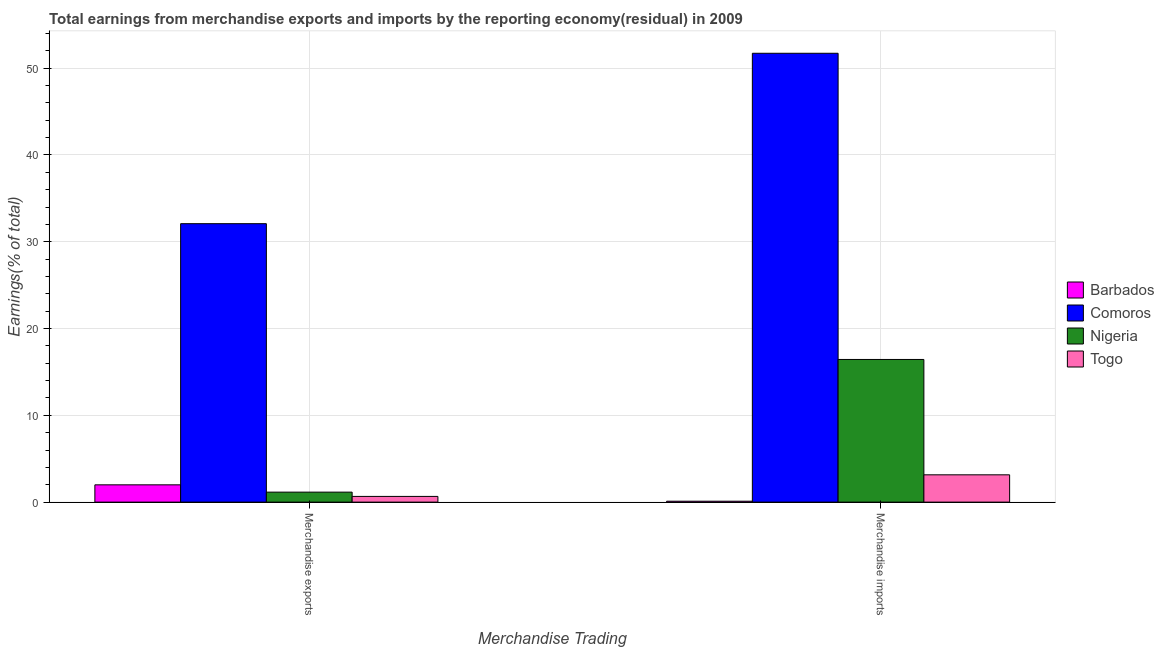Are the number of bars per tick equal to the number of legend labels?
Provide a short and direct response. Yes. How many bars are there on the 1st tick from the right?
Provide a succinct answer. 4. What is the label of the 2nd group of bars from the left?
Provide a succinct answer. Merchandise imports. What is the earnings from merchandise exports in Nigeria?
Your answer should be very brief. 1.15. Across all countries, what is the maximum earnings from merchandise exports?
Make the answer very short. 32.08. Across all countries, what is the minimum earnings from merchandise imports?
Provide a succinct answer. 0.1. In which country was the earnings from merchandise exports maximum?
Your answer should be compact. Comoros. In which country was the earnings from merchandise exports minimum?
Your answer should be very brief. Togo. What is the total earnings from merchandise exports in the graph?
Your response must be concise. 35.89. What is the difference between the earnings from merchandise exports in Barbados and that in Nigeria?
Your answer should be compact. 0.84. What is the difference between the earnings from merchandise imports in Togo and the earnings from merchandise exports in Comoros?
Your answer should be compact. -28.94. What is the average earnings from merchandise exports per country?
Your answer should be very brief. 8.97. What is the difference between the earnings from merchandise imports and earnings from merchandise exports in Comoros?
Provide a succinct answer. 19.64. What is the ratio of the earnings from merchandise exports in Togo to that in Barbados?
Provide a short and direct response. 0.33. In how many countries, is the earnings from merchandise exports greater than the average earnings from merchandise exports taken over all countries?
Make the answer very short. 1. What does the 4th bar from the left in Merchandise imports represents?
Provide a succinct answer. Togo. What does the 4th bar from the right in Merchandise imports represents?
Your answer should be very brief. Barbados. How many bars are there?
Your answer should be compact. 8. How many countries are there in the graph?
Make the answer very short. 4. What is the difference between two consecutive major ticks on the Y-axis?
Provide a succinct answer. 10. Are the values on the major ticks of Y-axis written in scientific E-notation?
Your response must be concise. No. How are the legend labels stacked?
Provide a succinct answer. Vertical. What is the title of the graph?
Keep it short and to the point. Total earnings from merchandise exports and imports by the reporting economy(residual) in 2009. Does "Haiti" appear as one of the legend labels in the graph?
Your answer should be compact. No. What is the label or title of the X-axis?
Provide a succinct answer. Merchandise Trading. What is the label or title of the Y-axis?
Offer a terse response. Earnings(% of total). What is the Earnings(% of total) of Barbados in Merchandise exports?
Your answer should be compact. 1.99. What is the Earnings(% of total) of Comoros in Merchandise exports?
Ensure brevity in your answer.  32.08. What is the Earnings(% of total) in Nigeria in Merchandise exports?
Keep it short and to the point. 1.15. What is the Earnings(% of total) of Togo in Merchandise exports?
Make the answer very short. 0.66. What is the Earnings(% of total) of Barbados in Merchandise imports?
Your answer should be very brief. 0.1. What is the Earnings(% of total) of Comoros in Merchandise imports?
Offer a very short reply. 51.72. What is the Earnings(% of total) in Nigeria in Merchandise imports?
Offer a terse response. 16.44. What is the Earnings(% of total) of Togo in Merchandise imports?
Provide a short and direct response. 3.15. Across all Merchandise Trading, what is the maximum Earnings(% of total) of Barbados?
Your answer should be very brief. 1.99. Across all Merchandise Trading, what is the maximum Earnings(% of total) of Comoros?
Keep it short and to the point. 51.72. Across all Merchandise Trading, what is the maximum Earnings(% of total) of Nigeria?
Offer a very short reply. 16.44. Across all Merchandise Trading, what is the maximum Earnings(% of total) in Togo?
Provide a succinct answer. 3.15. Across all Merchandise Trading, what is the minimum Earnings(% of total) of Barbados?
Offer a very short reply. 0.1. Across all Merchandise Trading, what is the minimum Earnings(% of total) in Comoros?
Provide a succinct answer. 32.08. Across all Merchandise Trading, what is the minimum Earnings(% of total) in Nigeria?
Keep it short and to the point. 1.15. Across all Merchandise Trading, what is the minimum Earnings(% of total) of Togo?
Ensure brevity in your answer.  0.66. What is the total Earnings(% of total) in Barbados in the graph?
Offer a terse response. 2.1. What is the total Earnings(% of total) of Comoros in the graph?
Offer a very short reply. 83.8. What is the total Earnings(% of total) in Nigeria in the graph?
Give a very brief answer. 17.59. What is the total Earnings(% of total) in Togo in the graph?
Offer a very short reply. 3.8. What is the difference between the Earnings(% of total) in Barbados in Merchandise exports and that in Merchandise imports?
Your response must be concise. 1.89. What is the difference between the Earnings(% of total) in Comoros in Merchandise exports and that in Merchandise imports?
Provide a short and direct response. -19.64. What is the difference between the Earnings(% of total) of Nigeria in Merchandise exports and that in Merchandise imports?
Your response must be concise. -15.29. What is the difference between the Earnings(% of total) in Togo in Merchandise exports and that in Merchandise imports?
Ensure brevity in your answer.  -2.49. What is the difference between the Earnings(% of total) of Barbados in Merchandise exports and the Earnings(% of total) of Comoros in Merchandise imports?
Give a very brief answer. -49.73. What is the difference between the Earnings(% of total) in Barbados in Merchandise exports and the Earnings(% of total) in Nigeria in Merchandise imports?
Make the answer very short. -14.45. What is the difference between the Earnings(% of total) in Barbados in Merchandise exports and the Earnings(% of total) in Togo in Merchandise imports?
Your answer should be very brief. -1.15. What is the difference between the Earnings(% of total) of Comoros in Merchandise exports and the Earnings(% of total) of Nigeria in Merchandise imports?
Offer a very short reply. 15.65. What is the difference between the Earnings(% of total) of Comoros in Merchandise exports and the Earnings(% of total) of Togo in Merchandise imports?
Offer a terse response. 28.94. What is the difference between the Earnings(% of total) in Nigeria in Merchandise exports and the Earnings(% of total) in Togo in Merchandise imports?
Provide a short and direct response. -1.99. What is the average Earnings(% of total) in Barbados per Merchandise Trading?
Keep it short and to the point. 1.05. What is the average Earnings(% of total) in Comoros per Merchandise Trading?
Keep it short and to the point. 41.9. What is the average Earnings(% of total) in Nigeria per Merchandise Trading?
Offer a terse response. 8.8. What is the average Earnings(% of total) in Togo per Merchandise Trading?
Provide a short and direct response. 1.9. What is the difference between the Earnings(% of total) in Barbados and Earnings(% of total) in Comoros in Merchandise exports?
Your answer should be very brief. -30.09. What is the difference between the Earnings(% of total) of Barbados and Earnings(% of total) of Nigeria in Merchandise exports?
Your answer should be compact. 0.84. What is the difference between the Earnings(% of total) in Barbados and Earnings(% of total) in Togo in Merchandise exports?
Provide a short and direct response. 1.34. What is the difference between the Earnings(% of total) of Comoros and Earnings(% of total) of Nigeria in Merchandise exports?
Make the answer very short. 30.93. What is the difference between the Earnings(% of total) of Comoros and Earnings(% of total) of Togo in Merchandise exports?
Your answer should be very brief. 31.43. What is the difference between the Earnings(% of total) in Nigeria and Earnings(% of total) in Togo in Merchandise exports?
Offer a very short reply. 0.49. What is the difference between the Earnings(% of total) of Barbados and Earnings(% of total) of Comoros in Merchandise imports?
Provide a succinct answer. -51.61. What is the difference between the Earnings(% of total) in Barbados and Earnings(% of total) in Nigeria in Merchandise imports?
Offer a terse response. -16.33. What is the difference between the Earnings(% of total) in Barbados and Earnings(% of total) in Togo in Merchandise imports?
Offer a very short reply. -3.04. What is the difference between the Earnings(% of total) in Comoros and Earnings(% of total) in Nigeria in Merchandise imports?
Keep it short and to the point. 35.28. What is the difference between the Earnings(% of total) in Comoros and Earnings(% of total) in Togo in Merchandise imports?
Make the answer very short. 48.57. What is the difference between the Earnings(% of total) in Nigeria and Earnings(% of total) in Togo in Merchandise imports?
Offer a terse response. 13.29. What is the ratio of the Earnings(% of total) in Barbados in Merchandise exports to that in Merchandise imports?
Make the answer very short. 19.05. What is the ratio of the Earnings(% of total) in Comoros in Merchandise exports to that in Merchandise imports?
Keep it short and to the point. 0.62. What is the ratio of the Earnings(% of total) of Nigeria in Merchandise exports to that in Merchandise imports?
Keep it short and to the point. 0.07. What is the ratio of the Earnings(% of total) in Togo in Merchandise exports to that in Merchandise imports?
Keep it short and to the point. 0.21. What is the difference between the highest and the second highest Earnings(% of total) of Barbados?
Offer a terse response. 1.89. What is the difference between the highest and the second highest Earnings(% of total) of Comoros?
Ensure brevity in your answer.  19.64. What is the difference between the highest and the second highest Earnings(% of total) of Nigeria?
Make the answer very short. 15.29. What is the difference between the highest and the second highest Earnings(% of total) in Togo?
Offer a very short reply. 2.49. What is the difference between the highest and the lowest Earnings(% of total) in Barbados?
Offer a very short reply. 1.89. What is the difference between the highest and the lowest Earnings(% of total) of Comoros?
Keep it short and to the point. 19.64. What is the difference between the highest and the lowest Earnings(% of total) in Nigeria?
Ensure brevity in your answer.  15.29. What is the difference between the highest and the lowest Earnings(% of total) in Togo?
Keep it short and to the point. 2.49. 